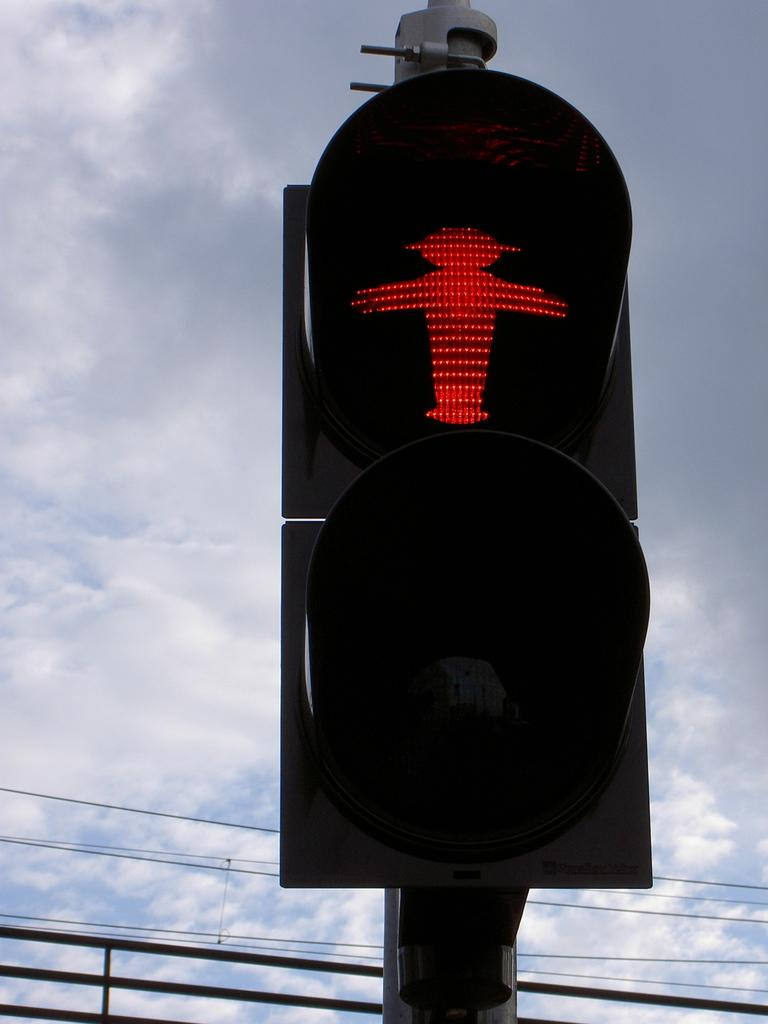What is the main object in the image? There is a traffic light in the image. What color lights are displayed on the traffic light? Red color lights are displayed on the traffic light. What can be seen in the backdrop of the image? There is a railing and cables present in the backdrop of the image. How would you describe the sky in the image? The sky is cloudy in the image. How many bits are attached to the hook in the image? There is no hook or bit present in the image; it features a traffic light with red lights and a backdrop of railing and cables. What type of beetle can be seen crawling on the traffic light in the image? There is no beetle present in the image; it only features a traffic light, railing, cables, and a cloudy sky. 